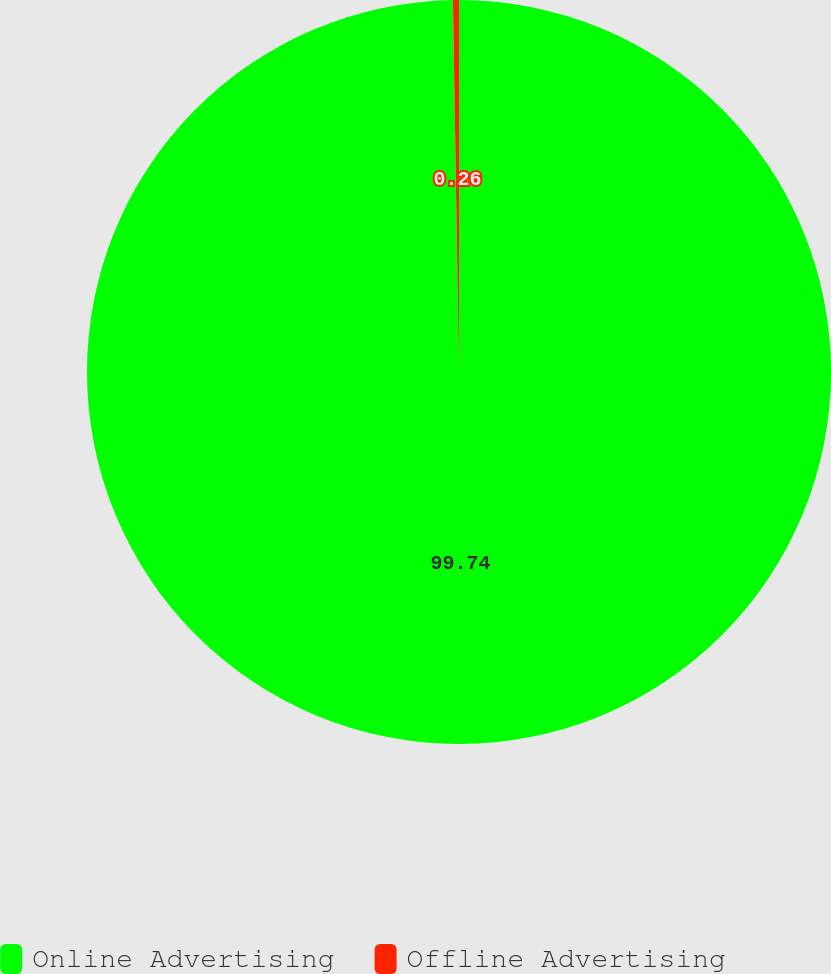Convert chart. <chart><loc_0><loc_0><loc_500><loc_500><pie_chart><fcel>Online Advertising<fcel>Offline Advertising<nl><fcel>99.74%<fcel>0.26%<nl></chart> 